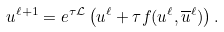<formula> <loc_0><loc_0><loc_500><loc_500>u ^ { \ell + 1 } = e ^ { \tau \mathcal { L } } \left ( u ^ { \ell } + \tau f ( u ^ { \ell } , \overline { u } ^ { \ell } ) \right ) .</formula> 